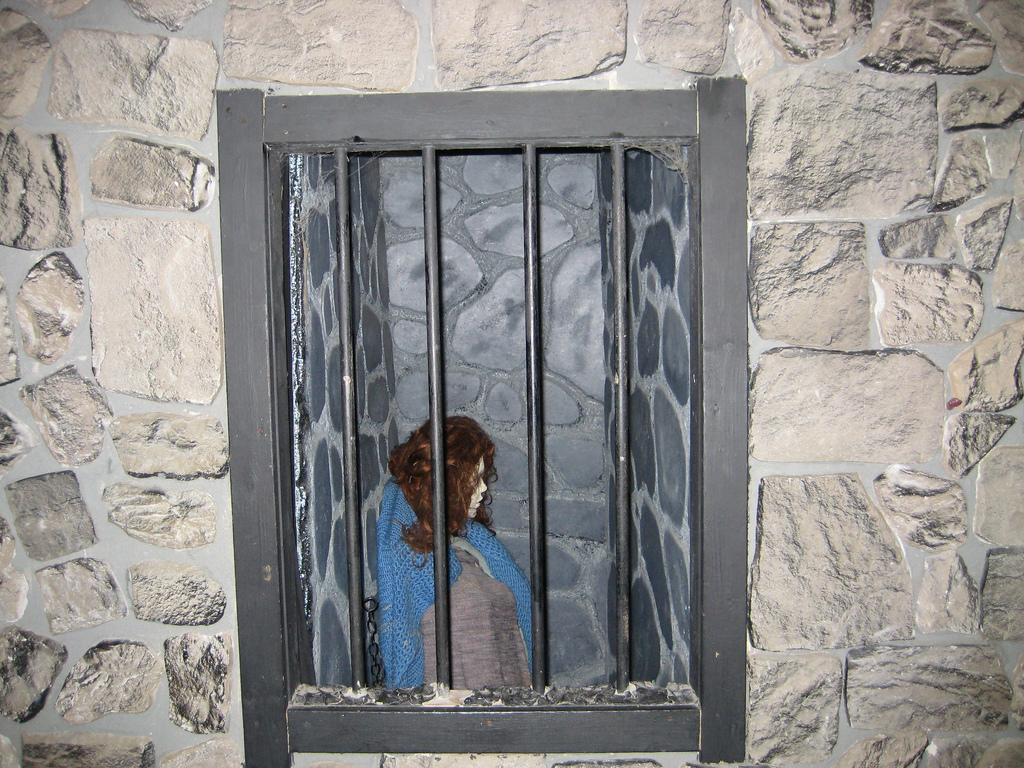What type of image is being described? The image is animated. What is happening in the animated image? There is a person inside a prison in the image. What can be seen on the sides of the image? There are walls on both the right and left sides of the image. What type of trousers is the person wearing in the image? There is no information about the person's clothing in the image, so it cannot be determined what type of trousers they might be wearing. 